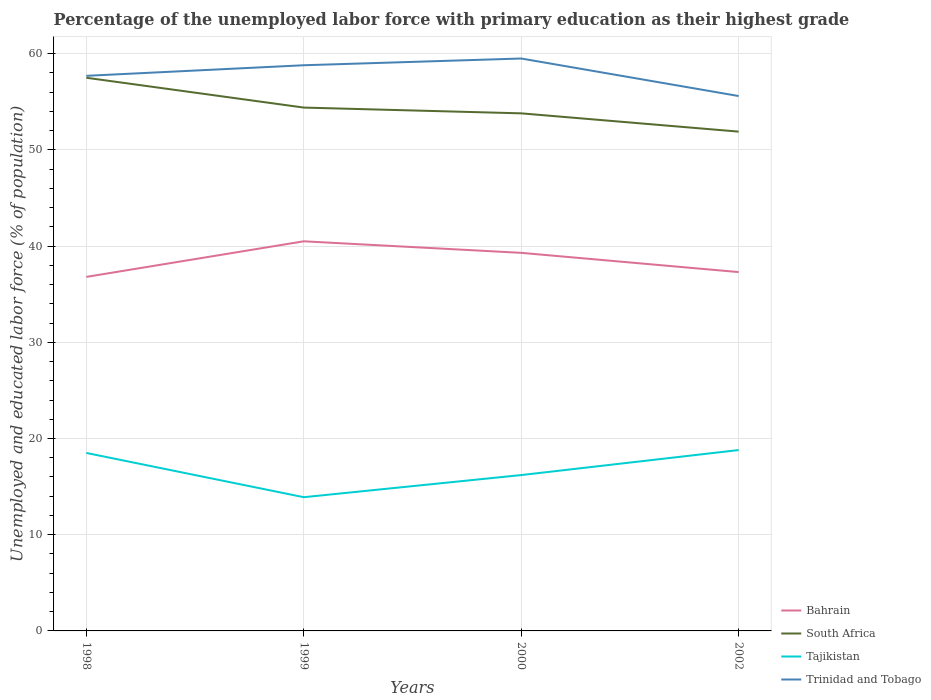How many different coloured lines are there?
Provide a succinct answer. 4. Does the line corresponding to Tajikistan intersect with the line corresponding to Trinidad and Tobago?
Make the answer very short. No. Is the number of lines equal to the number of legend labels?
Give a very brief answer. Yes. Across all years, what is the maximum percentage of the unemployed labor force with primary education in South Africa?
Your answer should be compact. 51.9. What is the total percentage of the unemployed labor force with primary education in Tajikistan in the graph?
Your answer should be compact. 4.6. What is the difference between the highest and the second highest percentage of the unemployed labor force with primary education in Bahrain?
Make the answer very short. 3.7. What is the difference between the highest and the lowest percentage of the unemployed labor force with primary education in Tajikistan?
Provide a succinct answer. 2. Is the percentage of the unemployed labor force with primary education in Bahrain strictly greater than the percentage of the unemployed labor force with primary education in South Africa over the years?
Provide a succinct answer. Yes. How many years are there in the graph?
Your response must be concise. 4. What is the difference between two consecutive major ticks on the Y-axis?
Your answer should be very brief. 10. Does the graph contain any zero values?
Ensure brevity in your answer.  No. What is the title of the graph?
Your answer should be very brief. Percentage of the unemployed labor force with primary education as their highest grade. Does "St. Vincent and the Grenadines" appear as one of the legend labels in the graph?
Your response must be concise. No. What is the label or title of the Y-axis?
Provide a succinct answer. Unemployed and educated labor force (% of population). What is the Unemployed and educated labor force (% of population) of Bahrain in 1998?
Offer a very short reply. 36.8. What is the Unemployed and educated labor force (% of population) in South Africa in 1998?
Offer a very short reply. 57.5. What is the Unemployed and educated labor force (% of population) in Tajikistan in 1998?
Provide a succinct answer. 18.5. What is the Unemployed and educated labor force (% of population) in Trinidad and Tobago in 1998?
Make the answer very short. 57.7. What is the Unemployed and educated labor force (% of population) in Bahrain in 1999?
Keep it short and to the point. 40.5. What is the Unemployed and educated labor force (% of population) of South Africa in 1999?
Offer a very short reply. 54.4. What is the Unemployed and educated labor force (% of population) in Tajikistan in 1999?
Make the answer very short. 13.9. What is the Unemployed and educated labor force (% of population) of Trinidad and Tobago in 1999?
Offer a terse response. 58.8. What is the Unemployed and educated labor force (% of population) of Bahrain in 2000?
Your answer should be very brief. 39.3. What is the Unemployed and educated labor force (% of population) in South Africa in 2000?
Give a very brief answer. 53.8. What is the Unemployed and educated labor force (% of population) in Tajikistan in 2000?
Your answer should be compact. 16.2. What is the Unemployed and educated labor force (% of population) in Trinidad and Tobago in 2000?
Provide a succinct answer. 59.5. What is the Unemployed and educated labor force (% of population) of Bahrain in 2002?
Keep it short and to the point. 37.3. What is the Unemployed and educated labor force (% of population) of South Africa in 2002?
Your answer should be compact. 51.9. What is the Unemployed and educated labor force (% of population) of Tajikistan in 2002?
Make the answer very short. 18.8. What is the Unemployed and educated labor force (% of population) of Trinidad and Tobago in 2002?
Make the answer very short. 55.6. Across all years, what is the maximum Unemployed and educated labor force (% of population) of Bahrain?
Keep it short and to the point. 40.5. Across all years, what is the maximum Unemployed and educated labor force (% of population) in South Africa?
Offer a very short reply. 57.5. Across all years, what is the maximum Unemployed and educated labor force (% of population) of Tajikistan?
Provide a succinct answer. 18.8. Across all years, what is the maximum Unemployed and educated labor force (% of population) of Trinidad and Tobago?
Provide a short and direct response. 59.5. Across all years, what is the minimum Unemployed and educated labor force (% of population) of Bahrain?
Make the answer very short. 36.8. Across all years, what is the minimum Unemployed and educated labor force (% of population) of South Africa?
Keep it short and to the point. 51.9. Across all years, what is the minimum Unemployed and educated labor force (% of population) of Tajikistan?
Offer a terse response. 13.9. Across all years, what is the minimum Unemployed and educated labor force (% of population) in Trinidad and Tobago?
Keep it short and to the point. 55.6. What is the total Unemployed and educated labor force (% of population) in Bahrain in the graph?
Ensure brevity in your answer.  153.9. What is the total Unemployed and educated labor force (% of population) of South Africa in the graph?
Make the answer very short. 217.6. What is the total Unemployed and educated labor force (% of population) of Tajikistan in the graph?
Provide a short and direct response. 67.4. What is the total Unemployed and educated labor force (% of population) of Trinidad and Tobago in the graph?
Your answer should be compact. 231.6. What is the difference between the Unemployed and educated labor force (% of population) of Bahrain in 1998 and that in 1999?
Provide a short and direct response. -3.7. What is the difference between the Unemployed and educated labor force (% of population) of Tajikistan in 1998 and that in 1999?
Your answer should be compact. 4.6. What is the difference between the Unemployed and educated labor force (% of population) of Trinidad and Tobago in 1998 and that in 1999?
Provide a succinct answer. -1.1. What is the difference between the Unemployed and educated labor force (% of population) in Bahrain in 1998 and that in 2000?
Give a very brief answer. -2.5. What is the difference between the Unemployed and educated labor force (% of population) of Bahrain in 1998 and that in 2002?
Provide a succinct answer. -0.5. What is the difference between the Unemployed and educated labor force (% of population) in Trinidad and Tobago in 1998 and that in 2002?
Offer a terse response. 2.1. What is the difference between the Unemployed and educated labor force (% of population) in Trinidad and Tobago in 1999 and that in 2000?
Ensure brevity in your answer.  -0.7. What is the difference between the Unemployed and educated labor force (% of population) of Bahrain in 1999 and that in 2002?
Offer a terse response. 3.2. What is the difference between the Unemployed and educated labor force (% of population) in South Africa in 1999 and that in 2002?
Your response must be concise. 2.5. What is the difference between the Unemployed and educated labor force (% of population) of Trinidad and Tobago in 1999 and that in 2002?
Your answer should be compact. 3.2. What is the difference between the Unemployed and educated labor force (% of population) in Tajikistan in 2000 and that in 2002?
Ensure brevity in your answer.  -2.6. What is the difference between the Unemployed and educated labor force (% of population) of Trinidad and Tobago in 2000 and that in 2002?
Your answer should be compact. 3.9. What is the difference between the Unemployed and educated labor force (% of population) of Bahrain in 1998 and the Unemployed and educated labor force (% of population) of South Africa in 1999?
Your answer should be very brief. -17.6. What is the difference between the Unemployed and educated labor force (% of population) of Bahrain in 1998 and the Unemployed and educated labor force (% of population) of Tajikistan in 1999?
Make the answer very short. 22.9. What is the difference between the Unemployed and educated labor force (% of population) of South Africa in 1998 and the Unemployed and educated labor force (% of population) of Tajikistan in 1999?
Your answer should be compact. 43.6. What is the difference between the Unemployed and educated labor force (% of population) of South Africa in 1998 and the Unemployed and educated labor force (% of population) of Trinidad and Tobago in 1999?
Provide a succinct answer. -1.3. What is the difference between the Unemployed and educated labor force (% of population) in Tajikistan in 1998 and the Unemployed and educated labor force (% of population) in Trinidad and Tobago in 1999?
Keep it short and to the point. -40.3. What is the difference between the Unemployed and educated labor force (% of population) of Bahrain in 1998 and the Unemployed and educated labor force (% of population) of Tajikistan in 2000?
Give a very brief answer. 20.6. What is the difference between the Unemployed and educated labor force (% of population) in Bahrain in 1998 and the Unemployed and educated labor force (% of population) in Trinidad and Tobago in 2000?
Offer a terse response. -22.7. What is the difference between the Unemployed and educated labor force (% of population) of South Africa in 1998 and the Unemployed and educated labor force (% of population) of Tajikistan in 2000?
Ensure brevity in your answer.  41.3. What is the difference between the Unemployed and educated labor force (% of population) of Tajikistan in 1998 and the Unemployed and educated labor force (% of population) of Trinidad and Tobago in 2000?
Provide a succinct answer. -41. What is the difference between the Unemployed and educated labor force (% of population) in Bahrain in 1998 and the Unemployed and educated labor force (% of population) in South Africa in 2002?
Provide a succinct answer. -15.1. What is the difference between the Unemployed and educated labor force (% of population) of Bahrain in 1998 and the Unemployed and educated labor force (% of population) of Trinidad and Tobago in 2002?
Your answer should be compact. -18.8. What is the difference between the Unemployed and educated labor force (% of population) of South Africa in 1998 and the Unemployed and educated labor force (% of population) of Tajikistan in 2002?
Give a very brief answer. 38.7. What is the difference between the Unemployed and educated labor force (% of population) of Tajikistan in 1998 and the Unemployed and educated labor force (% of population) of Trinidad and Tobago in 2002?
Your response must be concise. -37.1. What is the difference between the Unemployed and educated labor force (% of population) of Bahrain in 1999 and the Unemployed and educated labor force (% of population) of Tajikistan in 2000?
Offer a very short reply. 24.3. What is the difference between the Unemployed and educated labor force (% of population) of South Africa in 1999 and the Unemployed and educated labor force (% of population) of Tajikistan in 2000?
Give a very brief answer. 38.2. What is the difference between the Unemployed and educated labor force (% of population) in Tajikistan in 1999 and the Unemployed and educated labor force (% of population) in Trinidad and Tobago in 2000?
Keep it short and to the point. -45.6. What is the difference between the Unemployed and educated labor force (% of population) of Bahrain in 1999 and the Unemployed and educated labor force (% of population) of South Africa in 2002?
Offer a terse response. -11.4. What is the difference between the Unemployed and educated labor force (% of population) of Bahrain in 1999 and the Unemployed and educated labor force (% of population) of Tajikistan in 2002?
Ensure brevity in your answer.  21.7. What is the difference between the Unemployed and educated labor force (% of population) in Bahrain in 1999 and the Unemployed and educated labor force (% of population) in Trinidad and Tobago in 2002?
Give a very brief answer. -15.1. What is the difference between the Unemployed and educated labor force (% of population) of South Africa in 1999 and the Unemployed and educated labor force (% of population) of Tajikistan in 2002?
Make the answer very short. 35.6. What is the difference between the Unemployed and educated labor force (% of population) of South Africa in 1999 and the Unemployed and educated labor force (% of population) of Trinidad and Tobago in 2002?
Your answer should be very brief. -1.2. What is the difference between the Unemployed and educated labor force (% of population) in Tajikistan in 1999 and the Unemployed and educated labor force (% of population) in Trinidad and Tobago in 2002?
Keep it short and to the point. -41.7. What is the difference between the Unemployed and educated labor force (% of population) in Bahrain in 2000 and the Unemployed and educated labor force (% of population) in South Africa in 2002?
Your response must be concise. -12.6. What is the difference between the Unemployed and educated labor force (% of population) in Bahrain in 2000 and the Unemployed and educated labor force (% of population) in Tajikistan in 2002?
Keep it short and to the point. 20.5. What is the difference between the Unemployed and educated labor force (% of population) of Bahrain in 2000 and the Unemployed and educated labor force (% of population) of Trinidad and Tobago in 2002?
Keep it short and to the point. -16.3. What is the difference between the Unemployed and educated labor force (% of population) of South Africa in 2000 and the Unemployed and educated labor force (% of population) of Tajikistan in 2002?
Your answer should be very brief. 35. What is the difference between the Unemployed and educated labor force (% of population) in South Africa in 2000 and the Unemployed and educated labor force (% of population) in Trinidad and Tobago in 2002?
Offer a very short reply. -1.8. What is the difference between the Unemployed and educated labor force (% of population) of Tajikistan in 2000 and the Unemployed and educated labor force (% of population) of Trinidad and Tobago in 2002?
Keep it short and to the point. -39.4. What is the average Unemployed and educated labor force (% of population) in Bahrain per year?
Keep it short and to the point. 38.48. What is the average Unemployed and educated labor force (% of population) of South Africa per year?
Provide a succinct answer. 54.4. What is the average Unemployed and educated labor force (% of population) in Tajikistan per year?
Make the answer very short. 16.85. What is the average Unemployed and educated labor force (% of population) in Trinidad and Tobago per year?
Keep it short and to the point. 57.9. In the year 1998, what is the difference between the Unemployed and educated labor force (% of population) of Bahrain and Unemployed and educated labor force (% of population) of South Africa?
Offer a very short reply. -20.7. In the year 1998, what is the difference between the Unemployed and educated labor force (% of population) in Bahrain and Unemployed and educated labor force (% of population) in Trinidad and Tobago?
Your answer should be very brief. -20.9. In the year 1998, what is the difference between the Unemployed and educated labor force (% of population) of Tajikistan and Unemployed and educated labor force (% of population) of Trinidad and Tobago?
Provide a short and direct response. -39.2. In the year 1999, what is the difference between the Unemployed and educated labor force (% of population) of Bahrain and Unemployed and educated labor force (% of population) of South Africa?
Ensure brevity in your answer.  -13.9. In the year 1999, what is the difference between the Unemployed and educated labor force (% of population) of Bahrain and Unemployed and educated labor force (% of population) of Tajikistan?
Ensure brevity in your answer.  26.6. In the year 1999, what is the difference between the Unemployed and educated labor force (% of population) of Bahrain and Unemployed and educated labor force (% of population) of Trinidad and Tobago?
Offer a very short reply. -18.3. In the year 1999, what is the difference between the Unemployed and educated labor force (% of population) in South Africa and Unemployed and educated labor force (% of population) in Tajikistan?
Keep it short and to the point. 40.5. In the year 1999, what is the difference between the Unemployed and educated labor force (% of population) of Tajikistan and Unemployed and educated labor force (% of population) of Trinidad and Tobago?
Offer a terse response. -44.9. In the year 2000, what is the difference between the Unemployed and educated labor force (% of population) of Bahrain and Unemployed and educated labor force (% of population) of South Africa?
Offer a very short reply. -14.5. In the year 2000, what is the difference between the Unemployed and educated labor force (% of population) in Bahrain and Unemployed and educated labor force (% of population) in Tajikistan?
Provide a succinct answer. 23.1. In the year 2000, what is the difference between the Unemployed and educated labor force (% of population) of Bahrain and Unemployed and educated labor force (% of population) of Trinidad and Tobago?
Your answer should be very brief. -20.2. In the year 2000, what is the difference between the Unemployed and educated labor force (% of population) in South Africa and Unemployed and educated labor force (% of population) in Tajikistan?
Your answer should be compact. 37.6. In the year 2000, what is the difference between the Unemployed and educated labor force (% of population) of South Africa and Unemployed and educated labor force (% of population) of Trinidad and Tobago?
Your response must be concise. -5.7. In the year 2000, what is the difference between the Unemployed and educated labor force (% of population) in Tajikistan and Unemployed and educated labor force (% of population) in Trinidad and Tobago?
Make the answer very short. -43.3. In the year 2002, what is the difference between the Unemployed and educated labor force (% of population) of Bahrain and Unemployed and educated labor force (% of population) of South Africa?
Provide a short and direct response. -14.6. In the year 2002, what is the difference between the Unemployed and educated labor force (% of population) in Bahrain and Unemployed and educated labor force (% of population) in Tajikistan?
Keep it short and to the point. 18.5. In the year 2002, what is the difference between the Unemployed and educated labor force (% of population) in Bahrain and Unemployed and educated labor force (% of population) in Trinidad and Tobago?
Provide a succinct answer. -18.3. In the year 2002, what is the difference between the Unemployed and educated labor force (% of population) in South Africa and Unemployed and educated labor force (% of population) in Tajikistan?
Keep it short and to the point. 33.1. In the year 2002, what is the difference between the Unemployed and educated labor force (% of population) in Tajikistan and Unemployed and educated labor force (% of population) in Trinidad and Tobago?
Give a very brief answer. -36.8. What is the ratio of the Unemployed and educated labor force (% of population) in Bahrain in 1998 to that in 1999?
Provide a succinct answer. 0.91. What is the ratio of the Unemployed and educated labor force (% of population) of South Africa in 1998 to that in 1999?
Your response must be concise. 1.06. What is the ratio of the Unemployed and educated labor force (% of population) of Tajikistan in 1998 to that in 1999?
Provide a short and direct response. 1.33. What is the ratio of the Unemployed and educated labor force (% of population) of Trinidad and Tobago in 1998 to that in 1999?
Offer a terse response. 0.98. What is the ratio of the Unemployed and educated labor force (% of population) in Bahrain in 1998 to that in 2000?
Provide a short and direct response. 0.94. What is the ratio of the Unemployed and educated labor force (% of population) in South Africa in 1998 to that in 2000?
Offer a very short reply. 1.07. What is the ratio of the Unemployed and educated labor force (% of population) in Tajikistan in 1998 to that in 2000?
Your answer should be very brief. 1.14. What is the ratio of the Unemployed and educated labor force (% of population) in Trinidad and Tobago in 1998 to that in 2000?
Make the answer very short. 0.97. What is the ratio of the Unemployed and educated labor force (% of population) of Bahrain in 1998 to that in 2002?
Ensure brevity in your answer.  0.99. What is the ratio of the Unemployed and educated labor force (% of population) in South Africa in 1998 to that in 2002?
Your response must be concise. 1.11. What is the ratio of the Unemployed and educated labor force (% of population) of Trinidad and Tobago in 1998 to that in 2002?
Provide a short and direct response. 1.04. What is the ratio of the Unemployed and educated labor force (% of population) in Bahrain in 1999 to that in 2000?
Your response must be concise. 1.03. What is the ratio of the Unemployed and educated labor force (% of population) of South Africa in 1999 to that in 2000?
Your answer should be compact. 1.01. What is the ratio of the Unemployed and educated labor force (% of population) of Tajikistan in 1999 to that in 2000?
Keep it short and to the point. 0.86. What is the ratio of the Unemployed and educated labor force (% of population) of Trinidad and Tobago in 1999 to that in 2000?
Offer a very short reply. 0.99. What is the ratio of the Unemployed and educated labor force (% of population) in Bahrain in 1999 to that in 2002?
Ensure brevity in your answer.  1.09. What is the ratio of the Unemployed and educated labor force (% of population) in South Africa in 1999 to that in 2002?
Provide a succinct answer. 1.05. What is the ratio of the Unemployed and educated labor force (% of population) of Tajikistan in 1999 to that in 2002?
Provide a short and direct response. 0.74. What is the ratio of the Unemployed and educated labor force (% of population) in Trinidad and Tobago in 1999 to that in 2002?
Your answer should be compact. 1.06. What is the ratio of the Unemployed and educated labor force (% of population) of Bahrain in 2000 to that in 2002?
Provide a succinct answer. 1.05. What is the ratio of the Unemployed and educated labor force (% of population) in South Africa in 2000 to that in 2002?
Provide a succinct answer. 1.04. What is the ratio of the Unemployed and educated labor force (% of population) in Tajikistan in 2000 to that in 2002?
Keep it short and to the point. 0.86. What is the ratio of the Unemployed and educated labor force (% of population) in Trinidad and Tobago in 2000 to that in 2002?
Provide a succinct answer. 1.07. What is the difference between the highest and the second highest Unemployed and educated labor force (% of population) in Bahrain?
Ensure brevity in your answer.  1.2. What is the difference between the highest and the second highest Unemployed and educated labor force (% of population) of Tajikistan?
Offer a terse response. 0.3. What is the difference between the highest and the lowest Unemployed and educated labor force (% of population) of South Africa?
Offer a very short reply. 5.6. What is the difference between the highest and the lowest Unemployed and educated labor force (% of population) of Tajikistan?
Give a very brief answer. 4.9. 